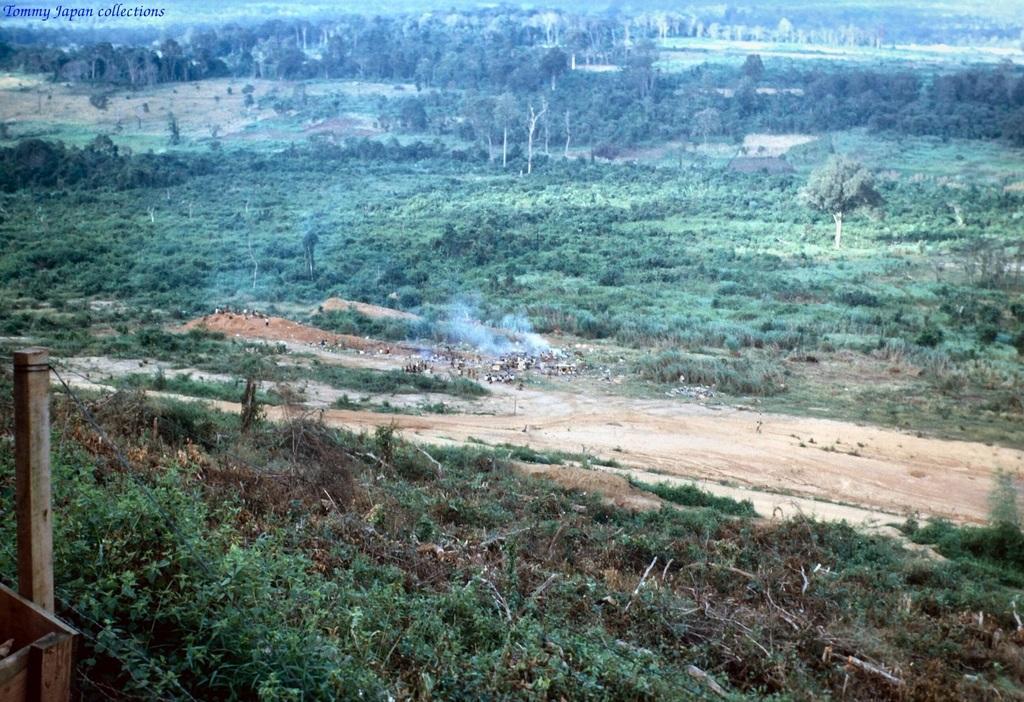Could you give a brief overview of what you see in this image? In this image we can see some trees, people and grass on the ground. 